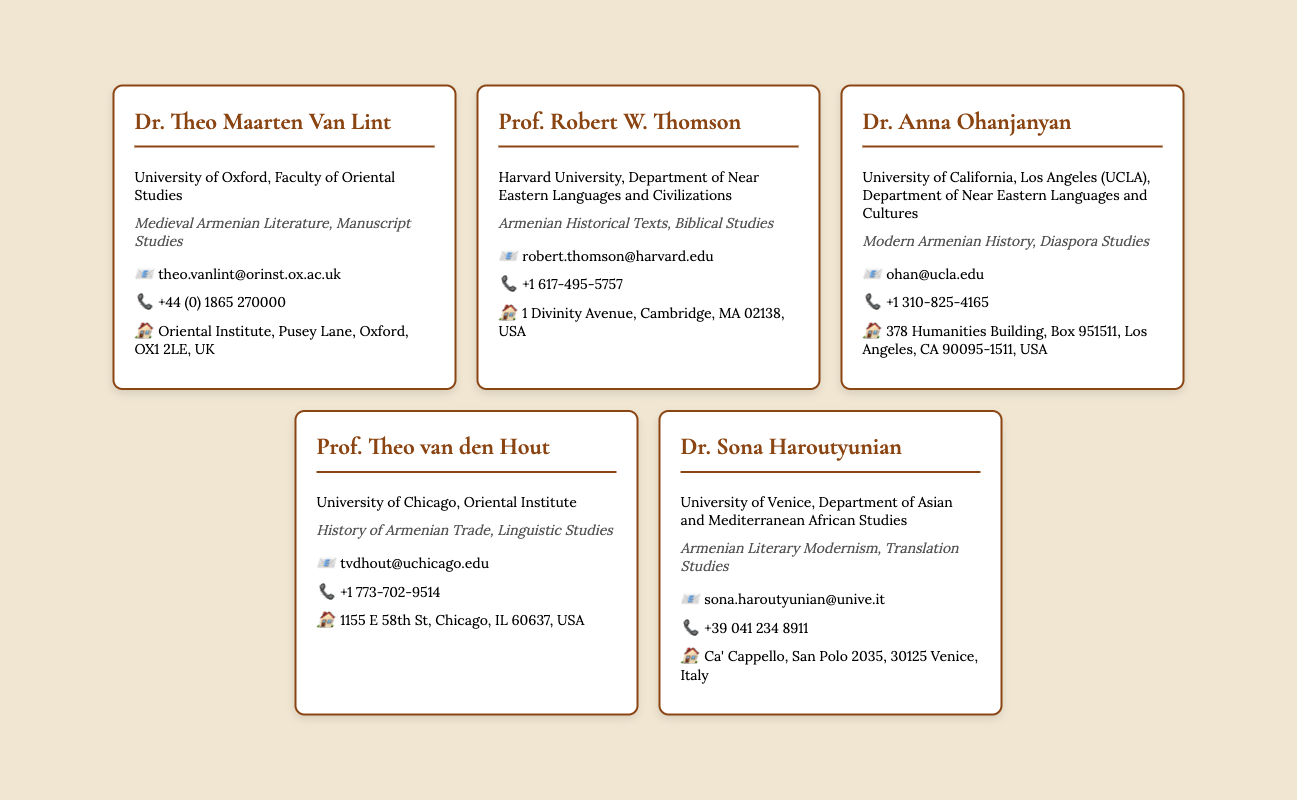What is Dr. Theo Maarten Van Lint's specialty? Dr. Theo Maarten Van Lint specializes in Medieval Armenian Literature and Manuscript Studies, as indicated in his card.
Answer: Medieval Armenian Literature, Manuscript Studies Which university is Prof. Robert W. Thomson affiliated with? Prof. Robert W. Thomson is affiliated with Harvard University, as mentioned in the document.
Answer: Harvard University What is the email address of Dr. Anna Ohanjanyan? The email address of Dr. Anna Ohanjanyan is listed in her contact information within the card.
Answer: ohan@ucla.edu How many scholars are listed in the document? The document contains information on five scholars as evidenced by the number of cards created.
Answer: Five What is the location of Prof. Theo van den Hout's office? Prof. Theo van den Hout's office location is mentioned in the contact information on his card.
Answer: 1155 E 58th St, Chicago, IL 60637, USA What specialty does Dr. Sona Haroutyunian focus on? Dr. Sona Haroutyunian focuses on Armenian Literary Modernism and Translation Studies, as described in her card.
Answer: Armenian Literary Modernism, Translation Studies What phone number can be used to reach Prof. Robert W. Thomson? The phone number provided on Prof. Robert W. Thomson's card can be used to contact him.
Answer: +1 617-495-5757 Which scholar is associated with UCLA? The scholar associated with UCLA is Dr. Anna Ohanjanyan, as stated in her affiliation.
Answer: Dr. Anna Ohanjanyan What does the card design feature to highlight the scholars? The card design features a background color, font styles, and a border to highlight the scholars' information.
Answer: A background color, font styles, and a border 